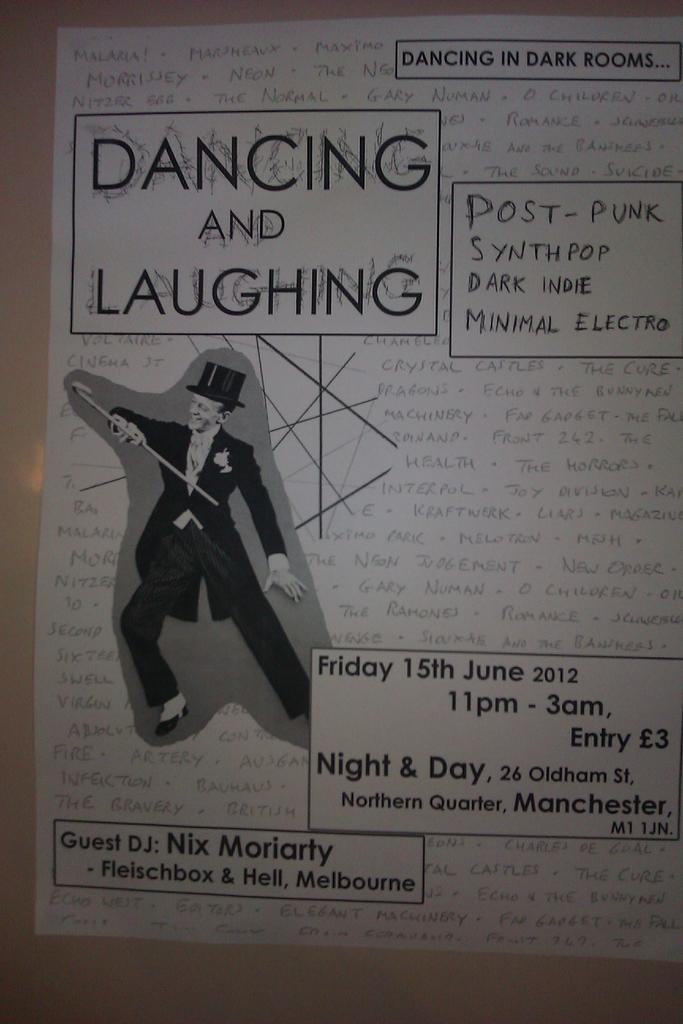<image>
Present a compact description of the photo's key features. A man in a top hat and tux is holding a cane on a poster for an event called Dancing and Laughing that takes place June 15th, at 11 pm. 